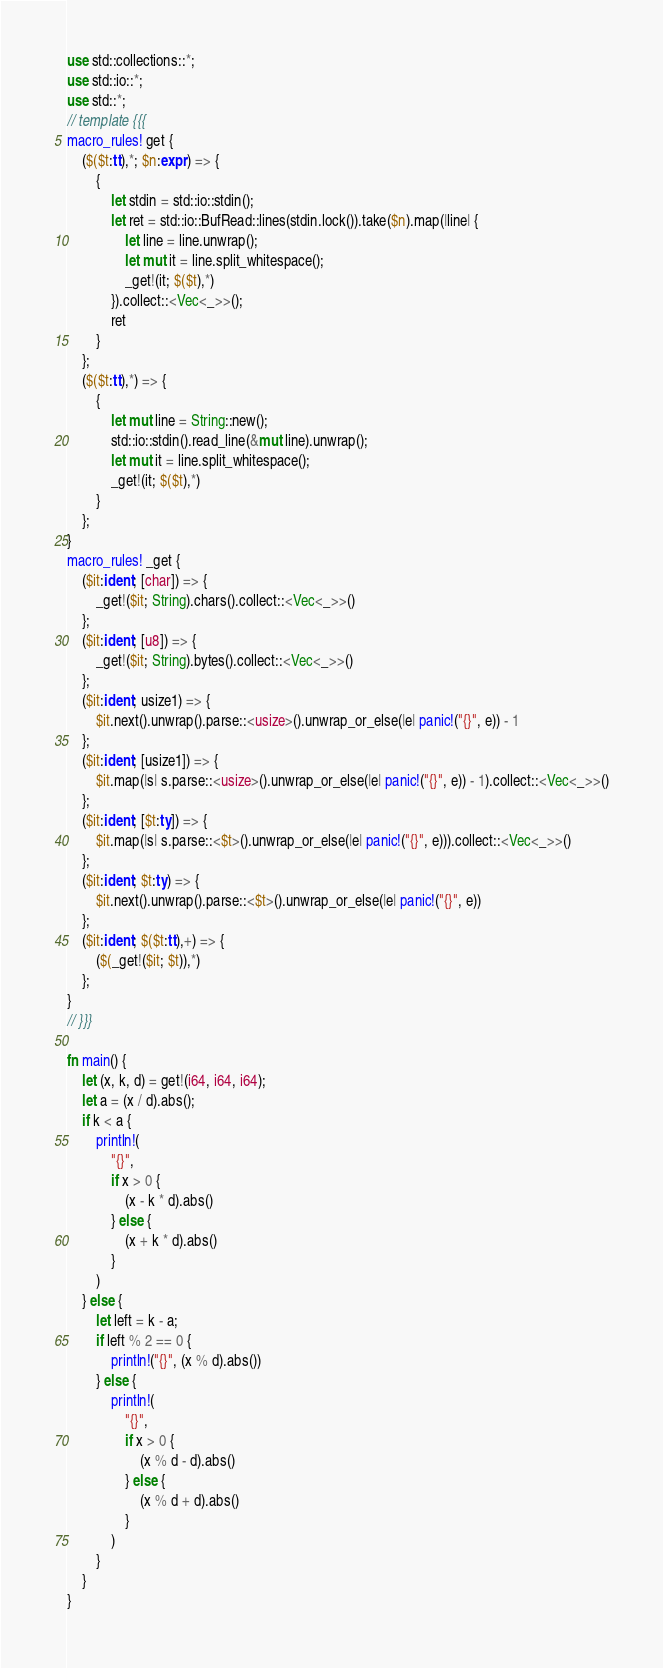<code> <loc_0><loc_0><loc_500><loc_500><_Rust_>use std::collections::*;
use std::io::*;
use std::*;
// template {{{
macro_rules! get {
    ($($t:tt),*; $n:expr) => {
        {
            let stdin = std::io::stdin();
            let ret = std::io::BufRead::lines(stdin.lock()).take($n).map(|line| {
                let line = line.unwrap();
                let mut it = line.split_whitespace();
                _get!(it; $($t),*)
            }).collect::<Vec<_>>();
            ret
        }
    };
    ($($t:tt),*) => {
        {
            let mut line = String::new();
            std::io::stdin().read_line(&mut line).unwrap();
            let mut it = line.split_whitespace();
            _get!(it; $($t),*)
        }
    };
}
macro_rules! _get {
    ($it:ident; [char]) => {
        _get!($it; String).chars().collect::<Vec<_>>()
    };
    ($it:ident; [u8]) => {
        _get!($it; String).bytes().collect::<Vec<_>>()
    };
    ($it:ident; usize1) => {
        $it.next().unwrap().parse::<usize>().unwrap_or_else(|e| panic!("{}", e)) - 1
    };
    ($it:ident; [usize1]) => {
        $it.map(|s| s.parse::<usize>().unwrap_or_else(|e| panic!("{}", e)) - 1).collect::<Vec<_>>()
    };
    ($it:ident; [$t:ty]) => {
        $it.map(|s| s.parse::<$t>().unwrap_or_else(|e| panic!("{}", e))).collect::<Vec<_>>()
    };
    ($it:ident; $t:ty) => {
        $it.next().unwrap().parse::<$t>().unwrap_or_else(|e| panic!("{}", e))
    };
    ($it:ident; $($t:tt),+) => {
        ($(_get!($it; $t)),*)
    };
}
// }}}

fn main() {
    let (x, k, d) = get!(i64, i64, i64);
    let a = (x / d).abs();
    if k < a {
        println!(
            "{}",
            if x > 0 {
                (x - k * d).abs()
            } else {
                (x + k * d).abs()
            }
        )
    } else {
        let left = k - a;
        if left % 2 == 0 {
            println!("{}", (x % d).abs())
        } else {
            println!(
                "{}",
                if x > 0 {
                    (x % d - d).abs()
                } else {
                    (x % d + d).abs()
                }
            )
        }
    }
}
</code> 